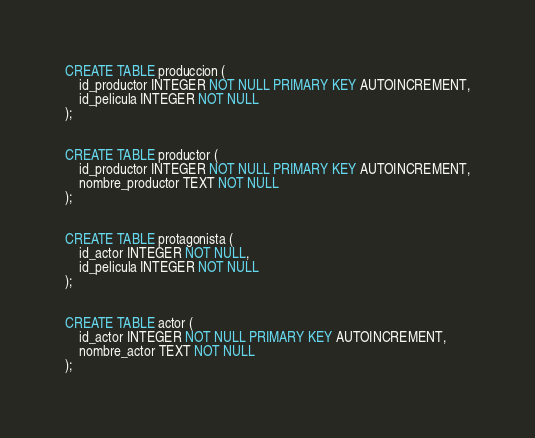<code> <loc_0><loc_0><loc_500><loc_500><_SQL_>
CREATE TABLE produccion (
	id_productor INTEGER NOT NULL PRIMARY KEY AUTOINCREMENT,
	id_pelicula INTEGER NOT NULL
);


CREATE TABLE productor (
	id_productor INTEGER NOT NULL PRIMARY KEY AUTOINCREMENT,
	nombre_productor TEXT NOT NULL
);


CREATE TABLE protagonista (
	id_actor INTEGER NOT NULL,
	id_pelicula INTEGER NOT NULL
);


CREATE TABLE actor (
	id_actor INTEGER NOT NULL PRIMARY KEY AUTOINCREMENT,
	nombre_actor TEXT NOT NULL
);
</code> 